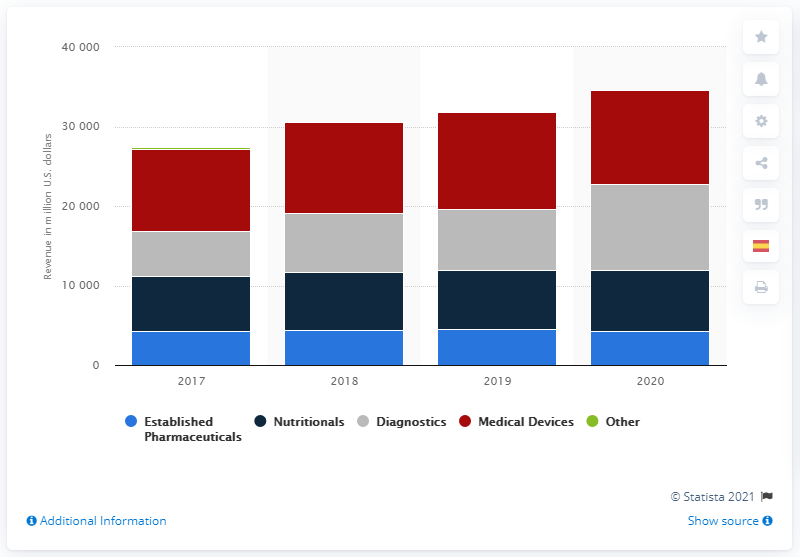Specify some key components in this picture. In the United States in 2020, the medical device segment generated approximately $11,787 million in revenue. In the United States in 2013, the diagnostics segment of Abbott generated approximately 10,805 revenue. 